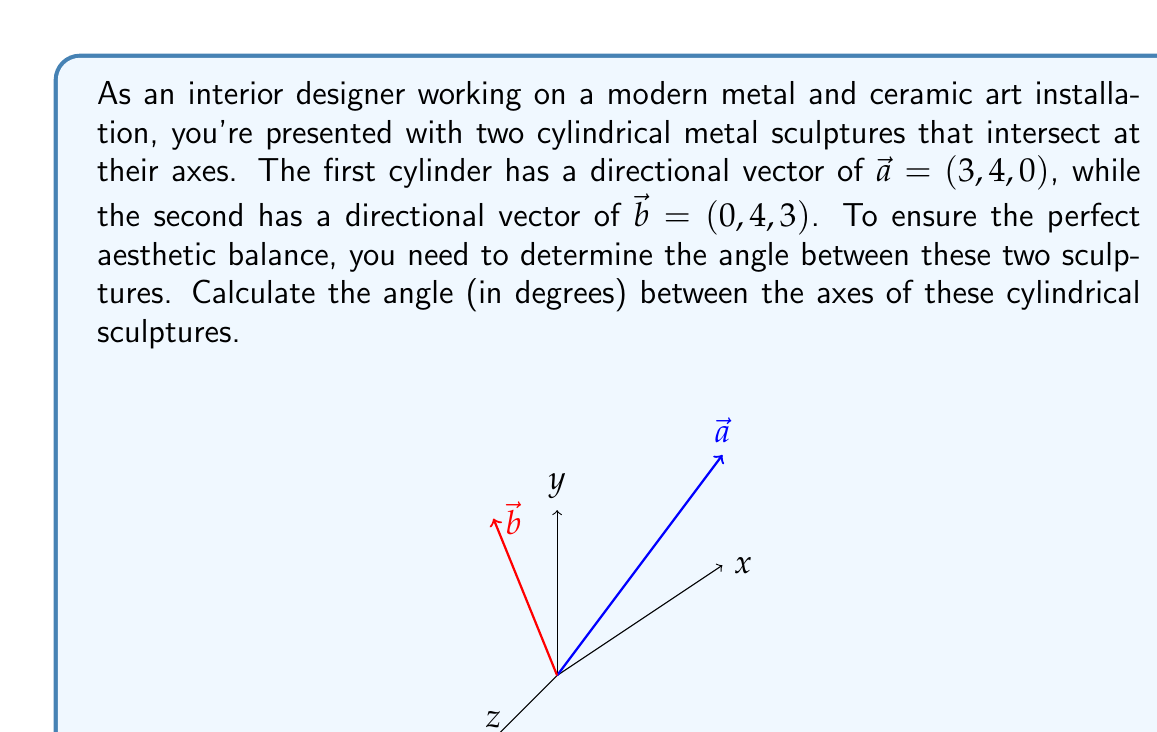Give your solution to this math problem. To find the angle between two vectors, we can use the dot product formula:

$$\cos \theta = \frac{\vec{a} \cdot \vec{b}}{|\vec{a}||\vec{b}|}$$

Step 1: Calculate the dot product $\vec{a} \cdot \vec{b}$
$\vec{a} \cdot \vec{b} = (3)(0) + (4)(4) + (0)(3) = 16$

Step 2: Calculate the magnitudes of $\vec{a}$ and $\vec{b}$
$|\vec{a}| = \sqrt{3^2 + 4^2 + 0^2} = \sqrt{25} = 5$
$|\vec{b}| = \sqrt{0^2 + 4^2 + 3^2} = \sqrt{25} = 5$

Step 3: Substitute into the formula
$$\cos \theta = \frac{16}{5 \cdot 5} = \frac{16}{25} = 0.64$$

Step 4: Take the inverse cosine (arccos) of both sides
$$\theta = \arccos(0.64)$$

Step 5: Convert to degrees
$$\theta = \arccos(0.64) \cdot \frac{180^{\circ}}{\pi} \approx 50.21^{\circ}$$
Answer: $50.21^{\circ}$ 